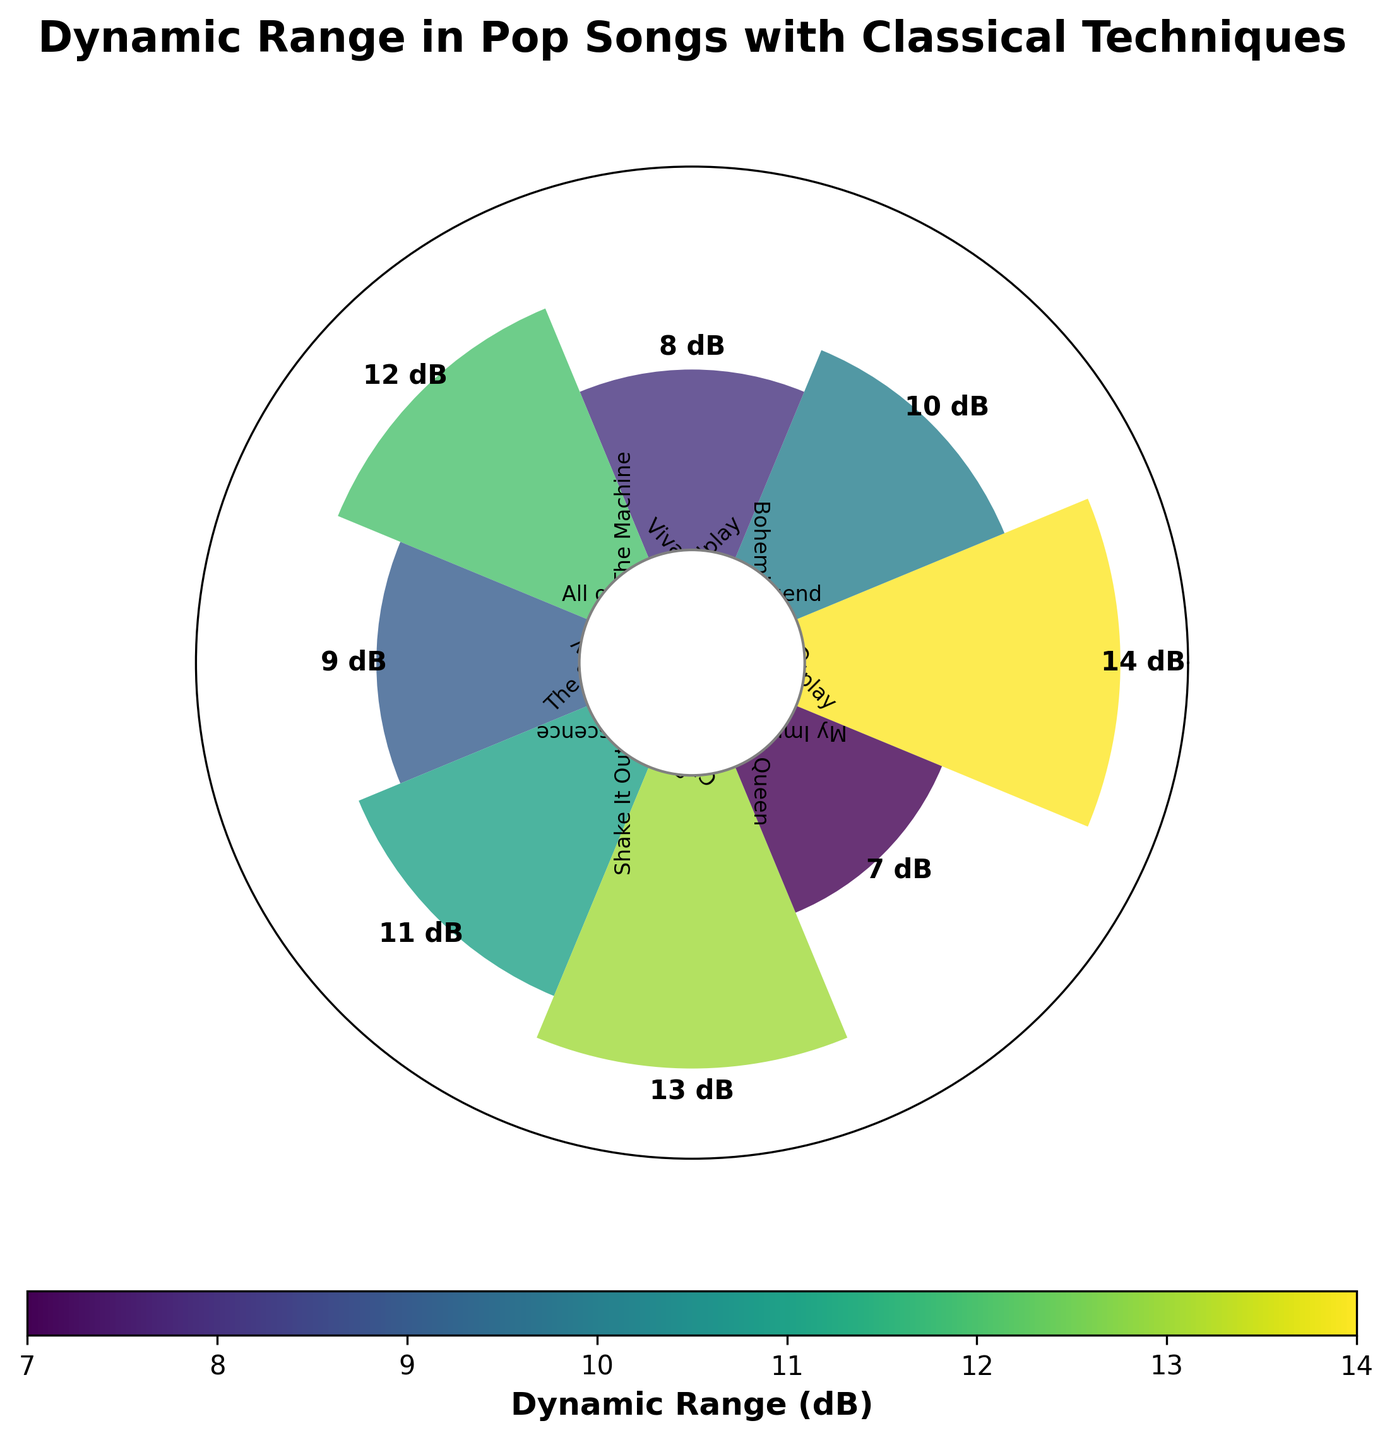What's the title of the figure? The title of the figure is placed at the top and reads "Dynamic Range in Pop Songs with Classical Techniques".
Answer: Dynamic Range in Pop Songs with Classical Techniques How many songs are represented in the figure? Count the number of distinct song titles mentioned around the plot. There are 8 songs.
Answer: 8 Which song has the highest dynamic range? Look for the bar that extends the furthest from the center. The song with the highest dynamic range is "Bohemian Rhapsody" by Queen with 14 dB.
Answer: "Bohemian Rhapsody" by Queen What is the dynamic range of the song "Chandelier" by Sia? Find the position of "Chandelier" by Sia and read its associated dynamic range. It shows 7 dB.
Answer: 7 dB Which song has a dynamic range of 11 dB? Look for the bar marked with 11 dB and identify the corresponding song. It's "Clocks" by Coldplay.
Answer: "Clocks" by Coldplay What's the average dynamic range of all the songs? Add all the dynamic range values and divide by the number of songs. (14 + 10 + 8 + 12 + 9 + 11 + 13 + 7) = 84, so the average is 84/8 = 10.5 dB.
Answer: 10.5 dB How many songs have a dynamic range greater than 10 dB? Count the number of songs with a dynamic range larger than 10 dB. They are "Bohemian Rhapsody", "The Scientist", "Clocks", and "My Immortal", so 4 songs.
Answer: 4 What's the difference in dynamic range between "Bohemian Rhapsody" and "Chandelier"? Subtract the dynamic range of "Chandelier" from that of "Bohemian Rhapsody". 14 dB - 7 dB = 7 dB.
Answer: 7 dB Which song has the lowest dynamic range? Look for the bar closest to the center. The song with the lowest dynamic range is "Chandelier" by Sia with 7 dB.
Answer: "Chandelier" by Sia Between "Viva La Vida" by Coldplay and "My Immortal" by Evanescence, which song has a higher dynamic range and by how much? Compare the dynamic ranges of "Viva La Vida" (10 dB) and "My Immortal" (13 dB). "My Immortal" has a higher dynamic range by 3 dB.
Answer: "My Immortal" by 3 dB 